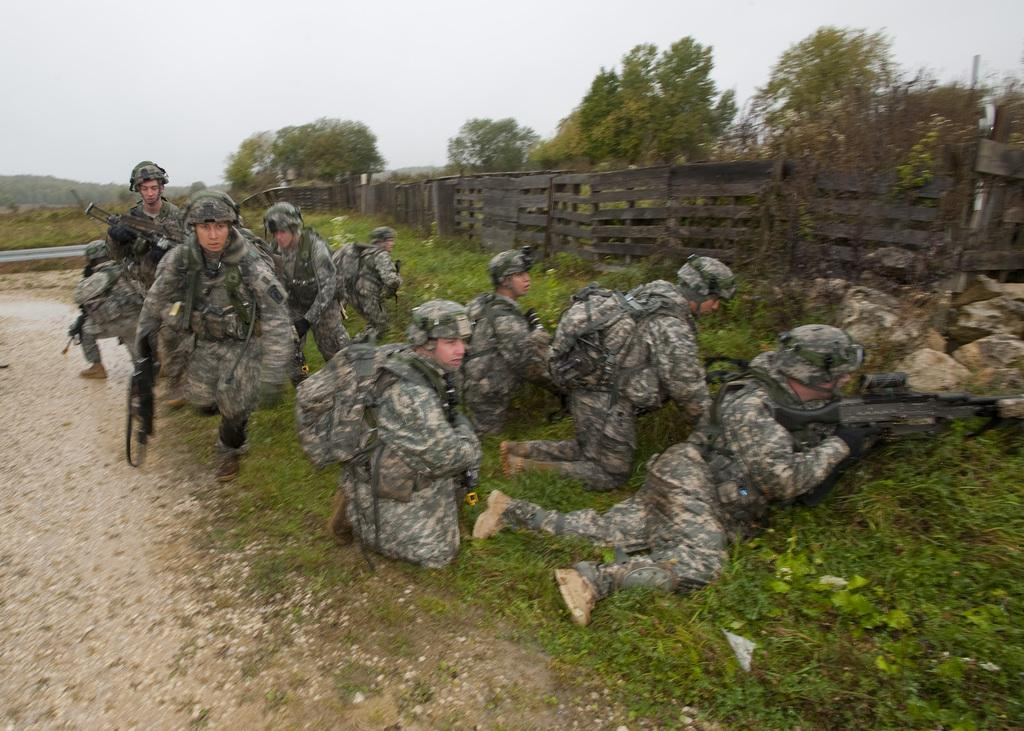How many people are in the group in the image? There is a group of people in the image, but the exact number is not specified. What are some people in the group holding? Some people in the group are holding guns. What type of vegetation can be seen in the image? There are plants and a group of trees present in the image. What is the ground made of in the image? Grass and stones are visible in the image. What is the condition of the sky in the image? The sky is visible in the image, and it looks cloudy. Can you tell me how many toads are hopping around in the image? There are no toads present in the image. What type of plant is being used as a nose accessory by one of the people in the image? There is no plant being used as a nose accessory by anyone in the image. 